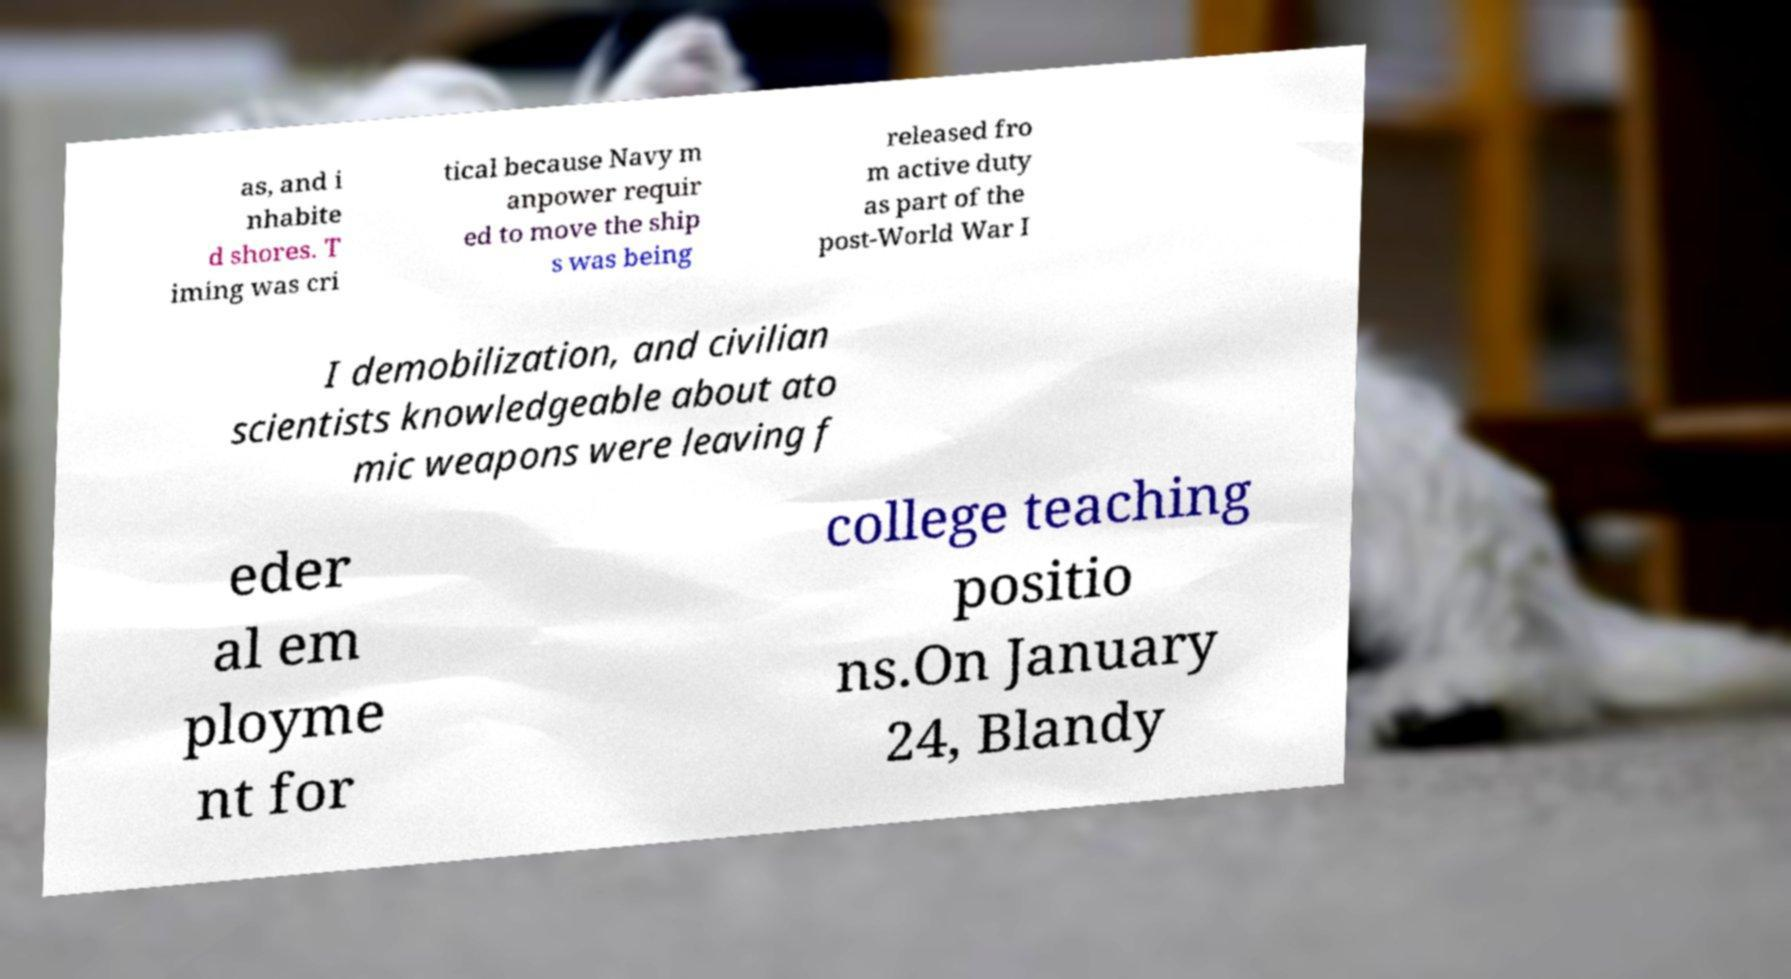What messages or text are displayed in this image? I need them in a readable, typed format. as, and i nhabite d shores. T iming was cri tical because Navy m anpower requir ed to move the ship s was being released fro m active duty as part of the post-World War I I demobilization, and civilian scientists knowledgeable about ato mic weapons were leaving f eder al em ployme nt for college teaching positio ns.On January 24, Blandy 